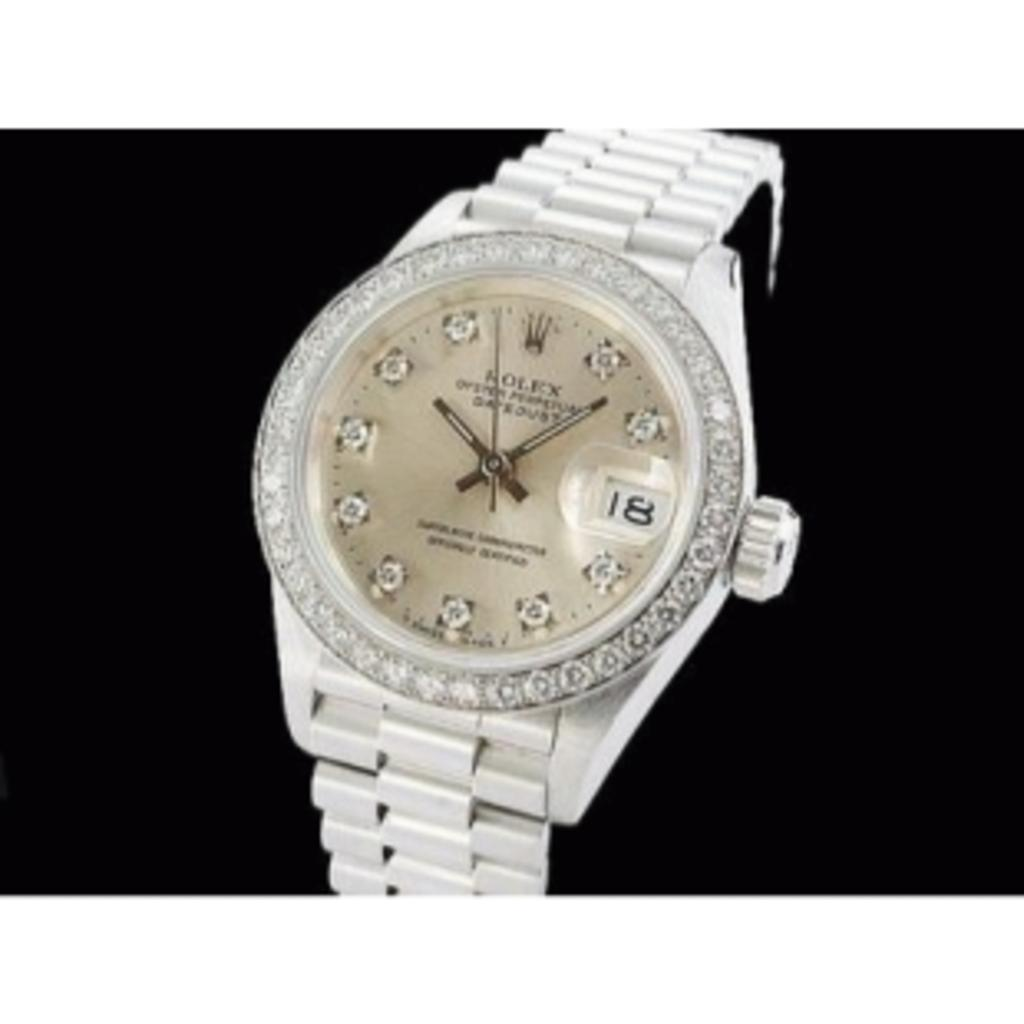Provide a one-sentence caption for the provided image. A silver women's Rolex watch covered in jewels and a gold face. 